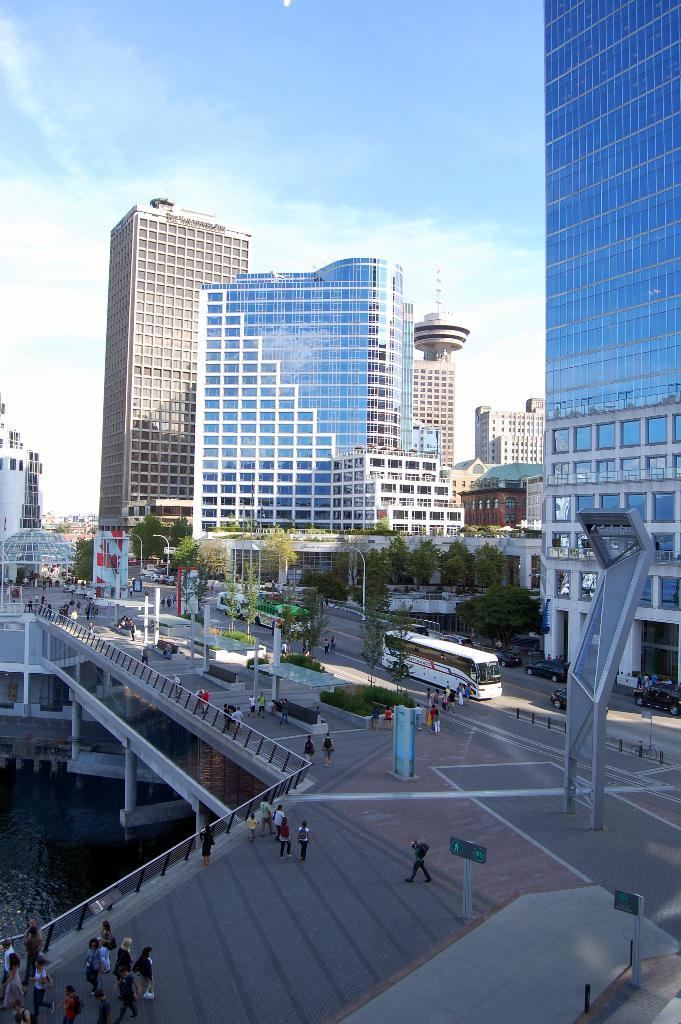What type of structures can be seen in the image? There are buildings, a tower, and a bridge in the image. What type of transportation is visible in the image? There are vehicles in the image. Are there any people present in the image? Yes, there are persons in the image. What type of natural elements can be seen in the image? There are trees and water visible in the image. What is visible in the sky in the image? There is sky, clouds, and a tower visible in the image. Can you tell me how many buckets are being used by the persons in the image? There is no mention of buckets in the image; they are not present. Is there a recess area for the vehicles to park in the image? There is no recess area specifically designated for vehicles in the image. 